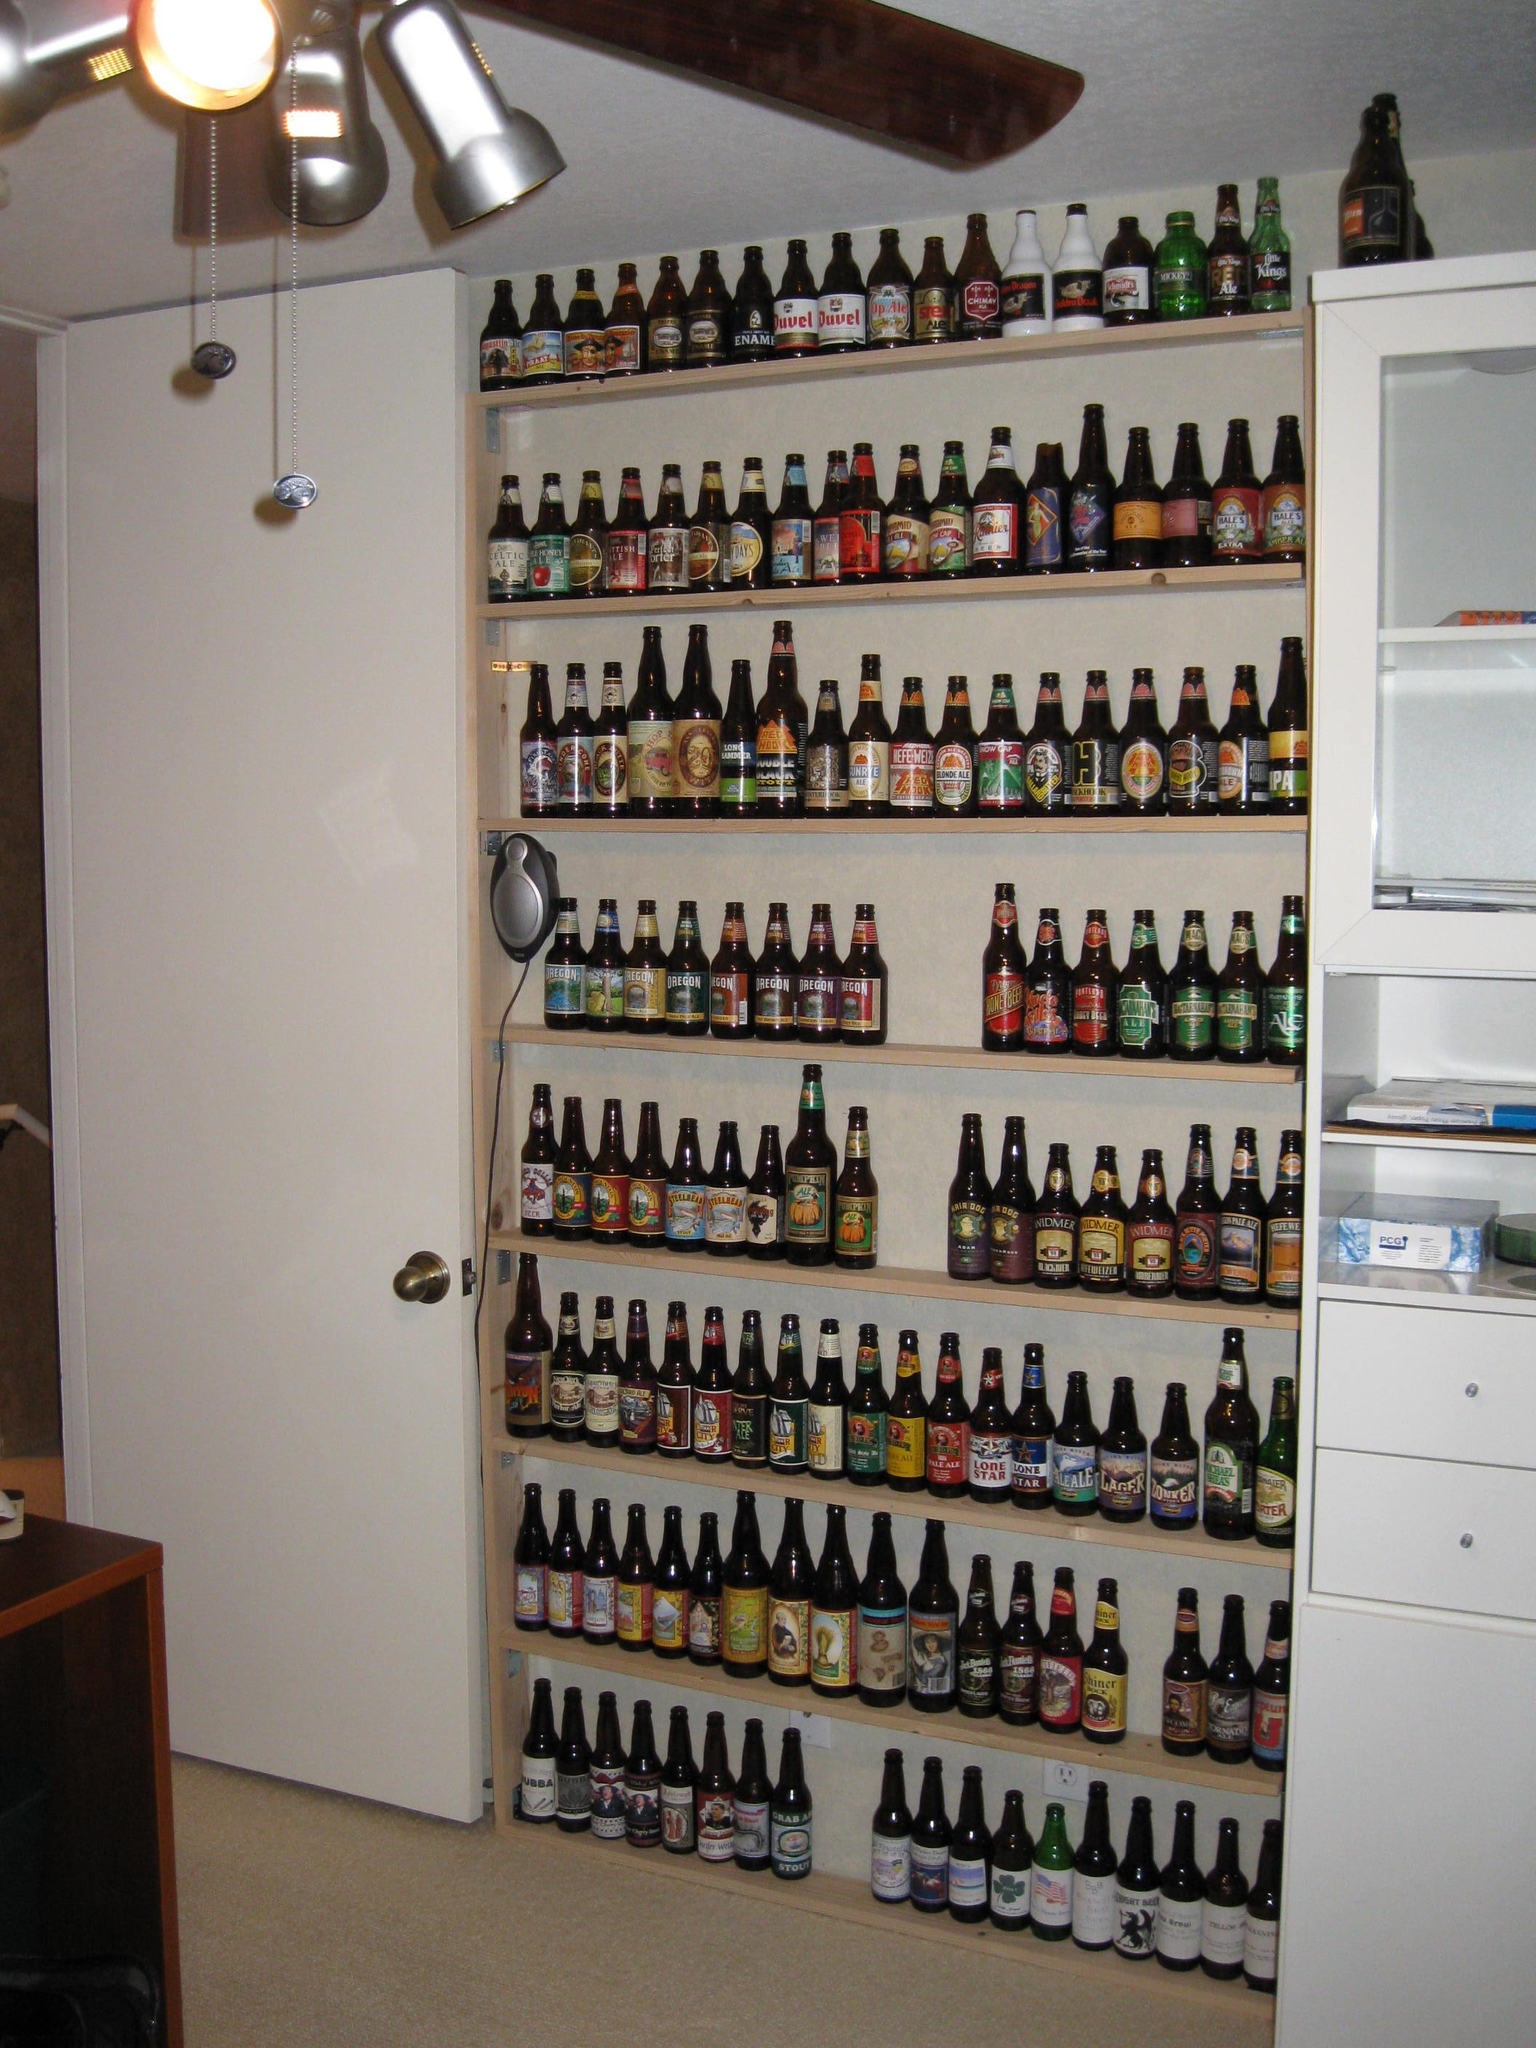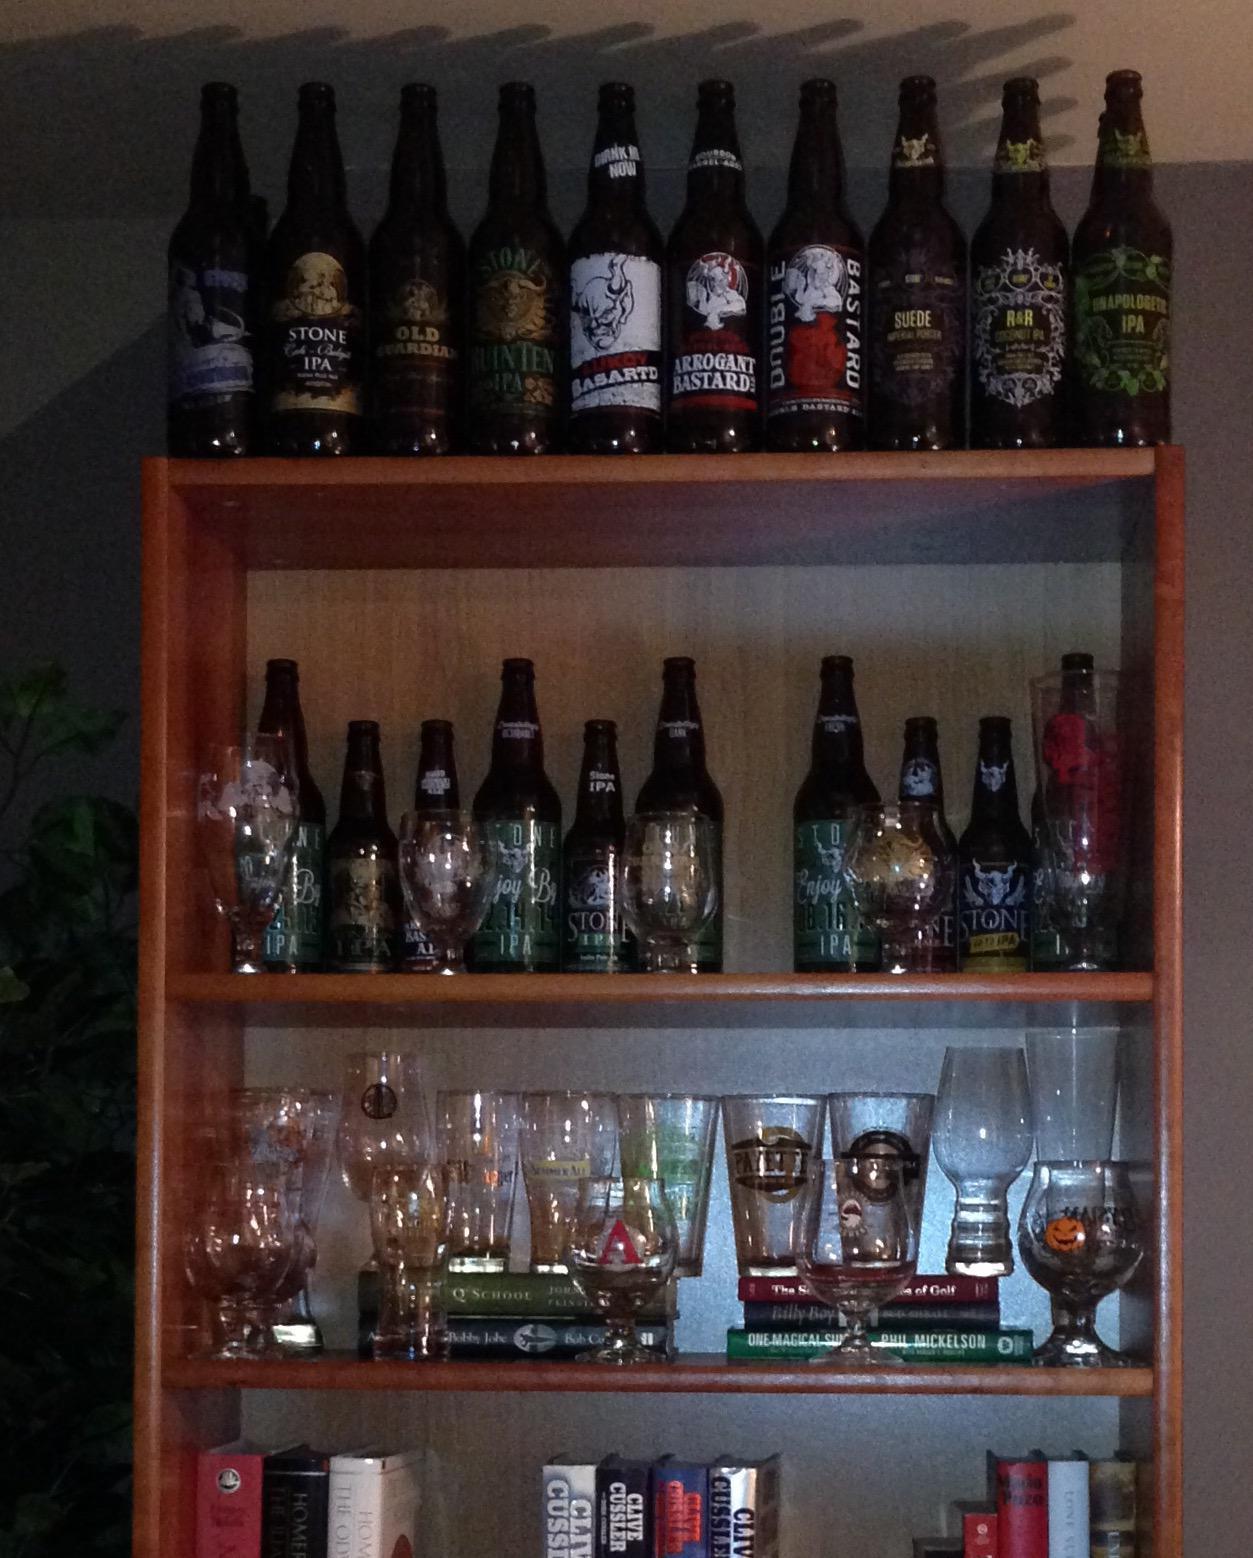The first image is the image on the left, the second image is the image on the right. Given the left and right images, does the statement "An image shows only one shelf with at least 13 bottles lined in a row." hold true? Answer yes or no. No. 